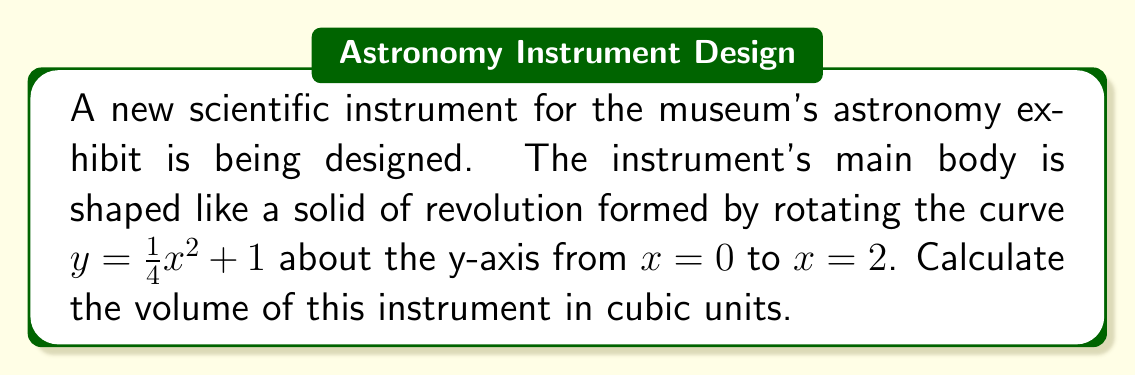Solve this math problem. To solve this problem, we'll use the shell method for calculating the volume of a solid of revolution. The steps are as follows:

1) The shell method formula for volume is:
   $$V = 2\pi \int_a^b x f(x) dx$$
   where $x$ is the radius of each shell and $f(x)$ is the height of each shell.

2) In this case, we're rotating around the y-axis, so $x$ represents the radius of each shell, and $y = \frac{1}{4}x^2 + 1$ represents the height of each shell.

3) We integrate from $x = 0$ to $x = 2$. Our integral becomes:
   $$V = 2\pi \int_0^2 x (\frac{1}{4}x^2 + 1) dx$$

4) Expand the integrand:
   $$V = 2\pi \int_0^2 (\frac{1}{4}x^3 + x) dx$$

5) Integrate:
   $$V = 2\pi [\frac{1}{16}x^4 + \frac{1}{2}x^2]_0^2$$

6) Evaluate the integral:
   $$V = 2\pi [(\frac{1}{16}(2^4) + \frac{1}{2}(2^2)) - (\frac{1}{16}(0^4) + \frac{1}{2}(0^2))]$$
   $$V = 2\pi [\frac{16}{16} + \frac{4}{2} - 0]$$
   $$V = 2\pi [1 + 2]$$
   $$V = 2\pi (3)$$
   $$V = 6\pi$$

Therefore, the volume of the instrument is $6\pi$ cubic units.
Answer: $6\pi$ cubic units 